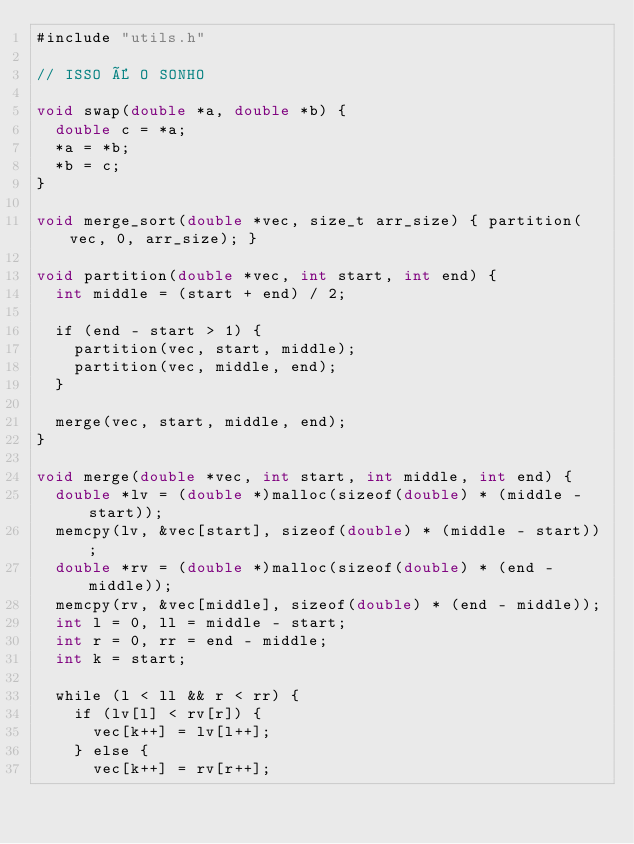<code> <loc_0><loc_0><loc_500><loc_500><_Cuda_>#include "utils.h"

// ISSO É O SONHO

void swap(double *a, double *b) {
  double c = *a;
  *a = *b;
  *b = c;
}

void merge_sort(double *vec, size_t arr_size) { partition(vec, 0, arr_size); }

void partition(double *vec, int start, int end) {
  int middle = (start + end) / 2;

  if (end - start > 1) {
    partition(vec, start, middle);
    partition(vec, middle, end);
  }

  merge(vec, start, middle, end);
}

void merge(double *vec, int start, int middle, int end) {
  double *lv = (double *)malloc(sizeof(double) * (middle - start));
  memcpy(lv, &vec[start], sizeof(double) * (middle - start));
  double *rv = (double *)malloc(sizeof(double) * (end - middle));
  memcpy(rv, &vec[middle], sizeof(double) * (end - middle));
  int l = 0, ll = middle - start;
  int r = 0, rr = end - middle;
  int k = start;

  while (l < ll && r < rr) {
    if (lv[l] < rv[r]) {
      vec[k++] = lv[l++];
    } else {
      vec[k++] = rv[r++];</code> 